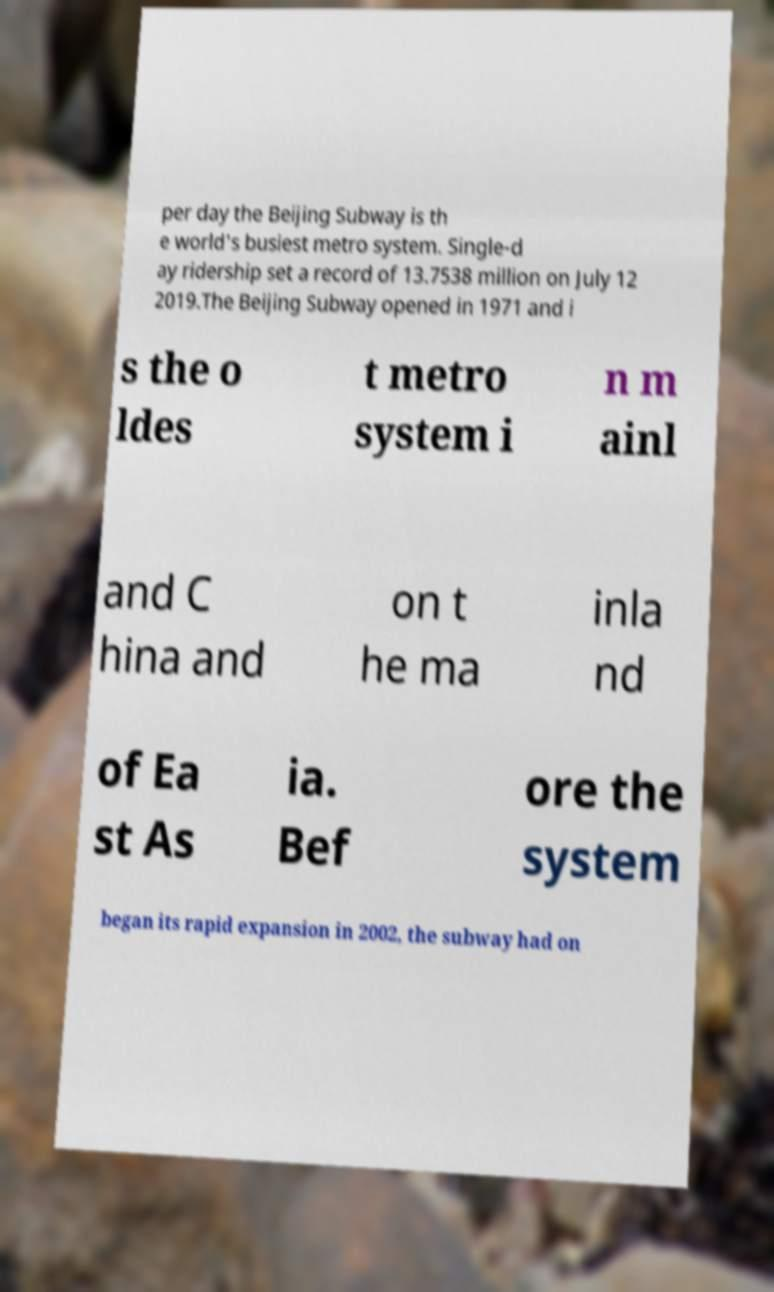There's text embedded in this image that I need extracted. Can you transcribe it verbatim? per day the Beijing Subway is th e world's busiest metro system. Single-d ay ridership set a record of 13.7538 million on July 12 2019.The Beijing Subway opened in 1971 and i s the o ldes t metro system i n m ainl and C hina and on t he ma inla nd of Ea st As ia. Bef ore the system began its rapid expansion in 2002, the subway had on 